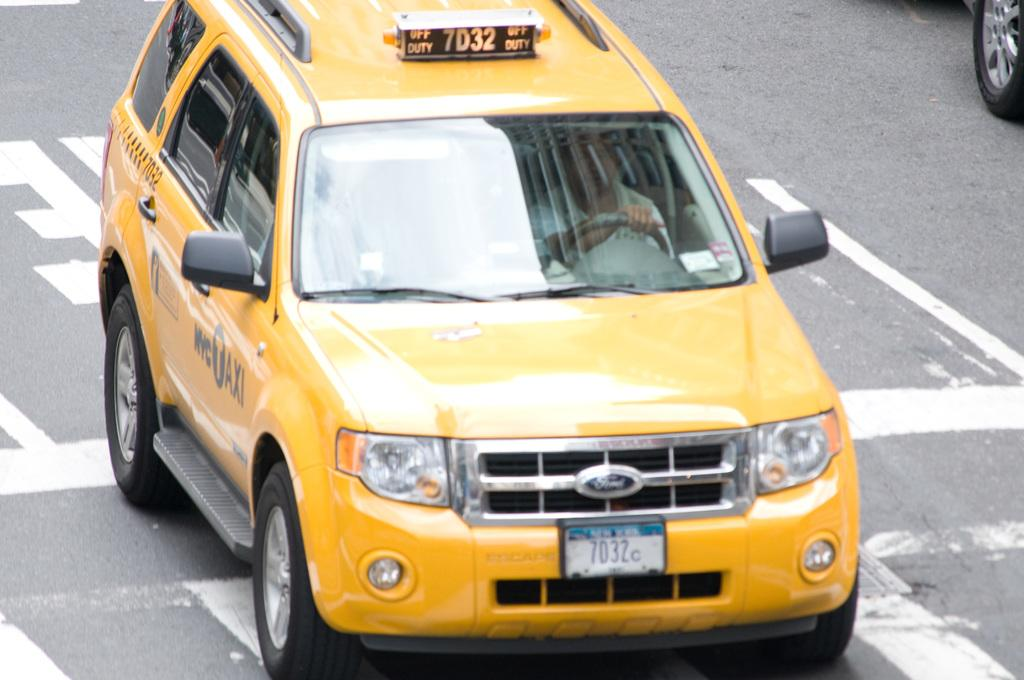<image>
Give a short and clear explanation of the subsequent image. Yellow taxi cab that has the number 7032 on the top. 